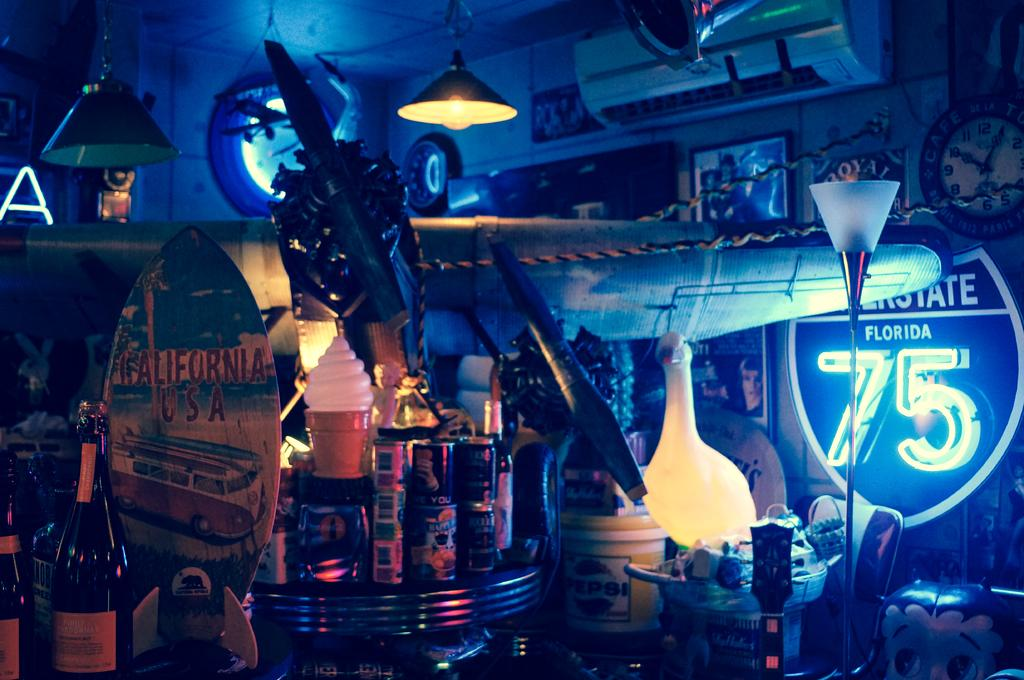<image>
Describe the image concisely. A bar filled with bottles and a lit up Interstate 75 Florida sign 